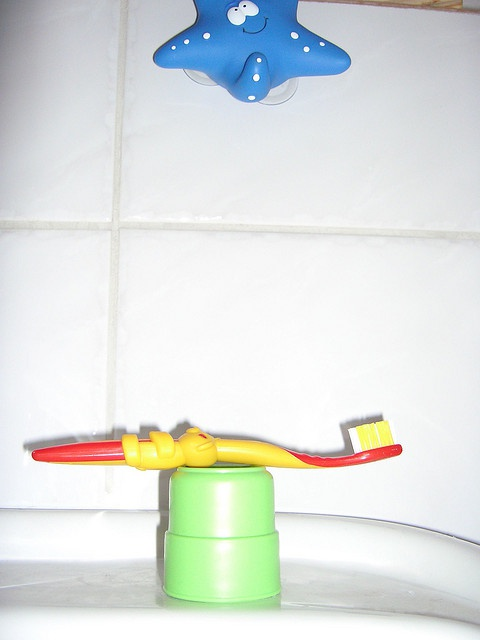Describe the objects in this image and their specific colors. I can see cup in gray, lightgreen, and lightyellow tones and toothbrush in gray, yellow, salmon, gold, and red tones in this image. 